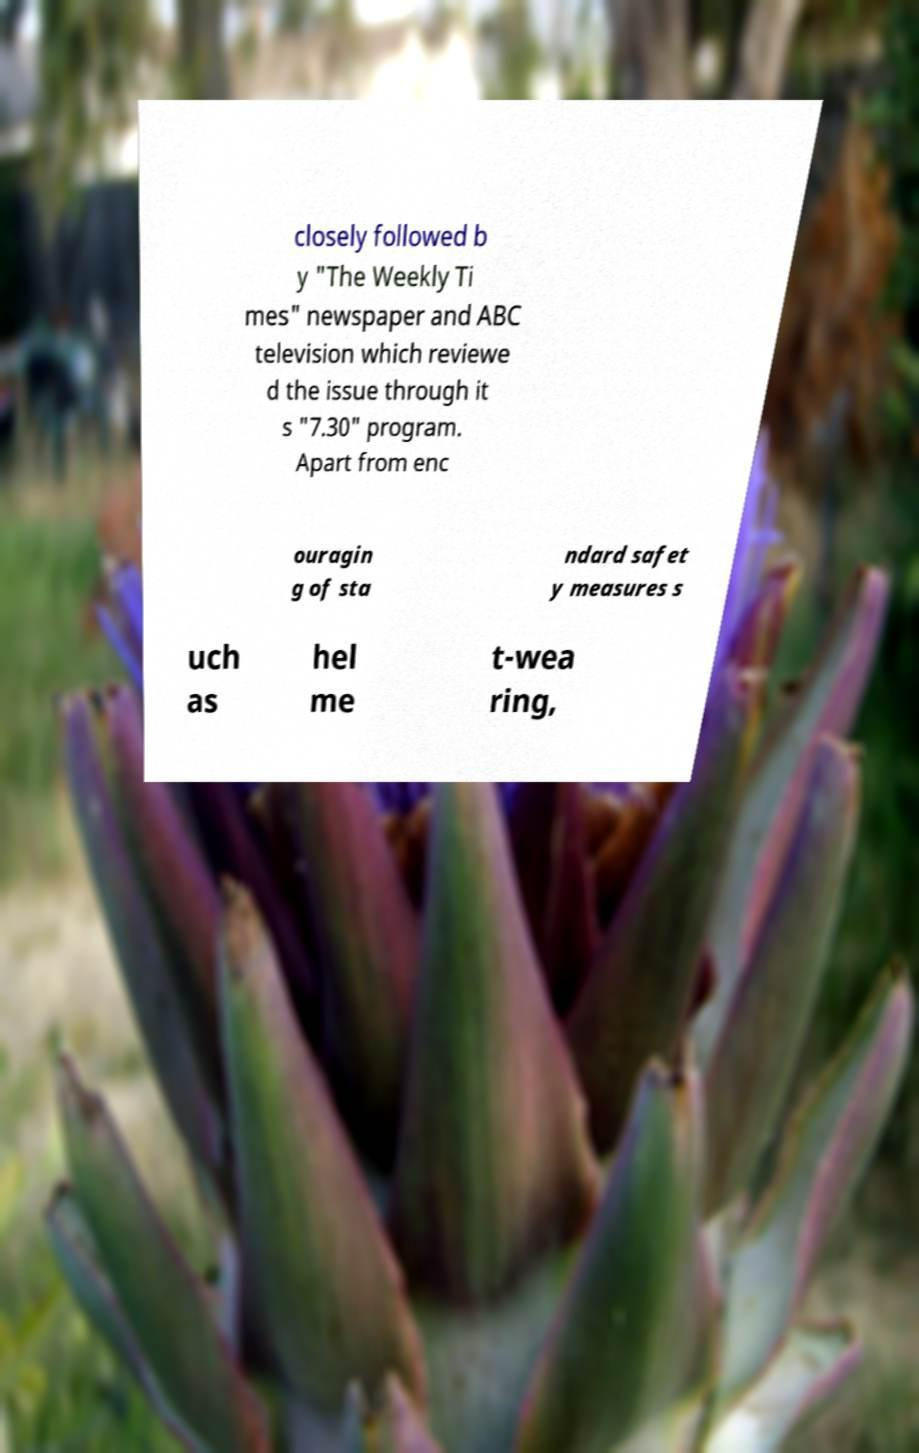Could you assist in decoding the text presented in this image and type it out clearly? closely followed b y "The Weekly Ti mes" newspaper and ABC television which reviewe d the issue through it s "7.30" program. Apart from enc ouragin g of sta ndard safet y measures s uch as hel me t-wea ring, 